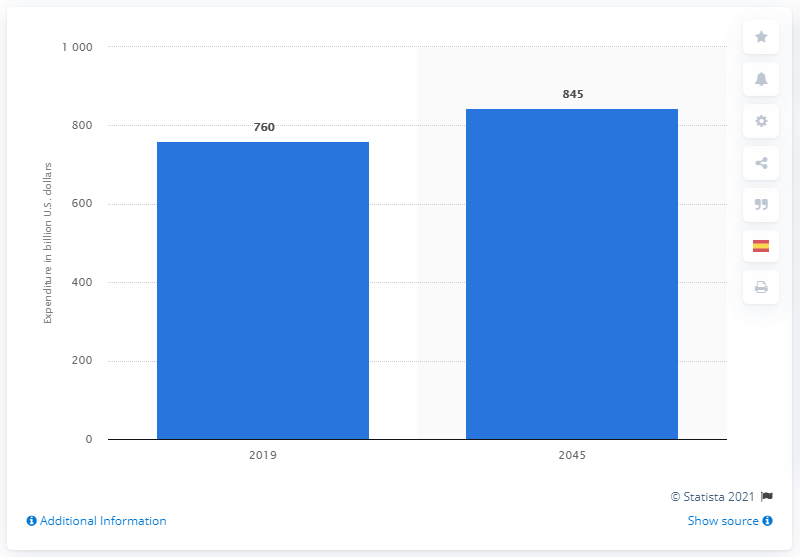Draw attention to some important aspects in this diagram. The global expenditure for diabetes treatment is expected to increase from 2019 to 2045, with an estimated growth of 845%. The estimated global expenditure for diabetes treatment between 2019 and 2045 is expected to be approximately 760 billion dollars. 